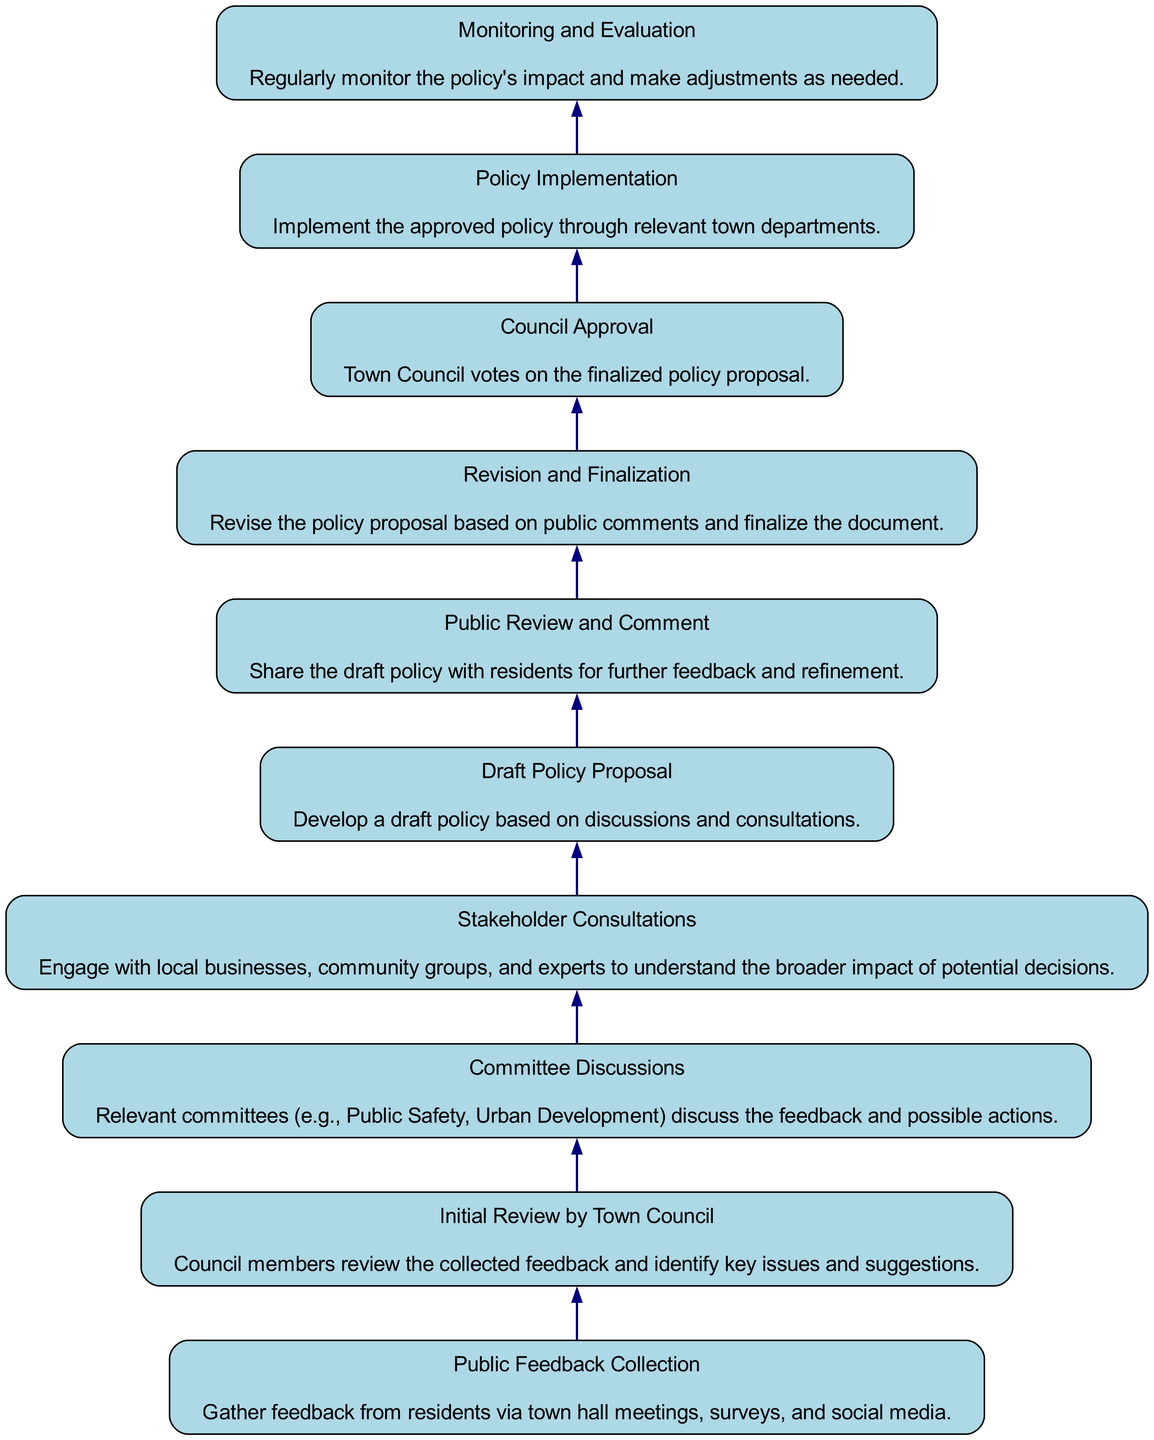What is the first step in the decision-making process? The first step in the diagram is "Public Feedback Collection". This is the starting point where feedback is gathered from residents.
Answer: Public Feedback Collection How many major steps are illustrated in the decision-making process? There are 10 major steps shown in the diagram, which range from public feedback collection to monitoring and evaluation.
Answer: 10 Which step directly follows "Draft Policy Proposal"? The step that directly follows "Draft Policy Proposal" is "Public Review and Comment". This indicates the order of actions taken after creating the draft policy.
Answer: Public Review and Comment What is the last step in the decision-making process? The last step in the diagram is "Monitoring and Evaluation". It signifies the ongoing assessment of the policy's impact following its implementation.
Answer: Monitoring and Evaluation Which two steps are connected by a direct edge between "Revision and Finalization" and "Council Approval"? The direct connection is between "Revision and Finalization" and "Council Approval". This shows that the council's approval comes after the policy revision has been completed.
Answer: Council Approval How are "Committee Discussions" and "Stakeholder Consultations" related in the diagram? "Committee Discussions" precede "Stakeholder Consultations" in the flow, indicating that the committees first discuss the feedback before engaging with stakeholders.
Answer: Sequential relationship What is the main purpose of the "Initial Review by Town Council"? The purpose is to identify key issues and suggestions from the public feedback that will guide further discussions and decisions.
Answer: Identify key issues and suggestions What step occurs before "Policy Implementation"? The step that occurs before "Policy Implementation" is "Council Approval". This is essential as a policy must be approved by the Council before it can be implemented.
Answer: Council Approval What decision follows "Public Review and Comment"? The decision that follows "Public Review and Comment" is "Revision and Finalization". This indicates that feedback from the public leads to revisions in the draft policy before finalization.
Answer: Revision and Finalization 